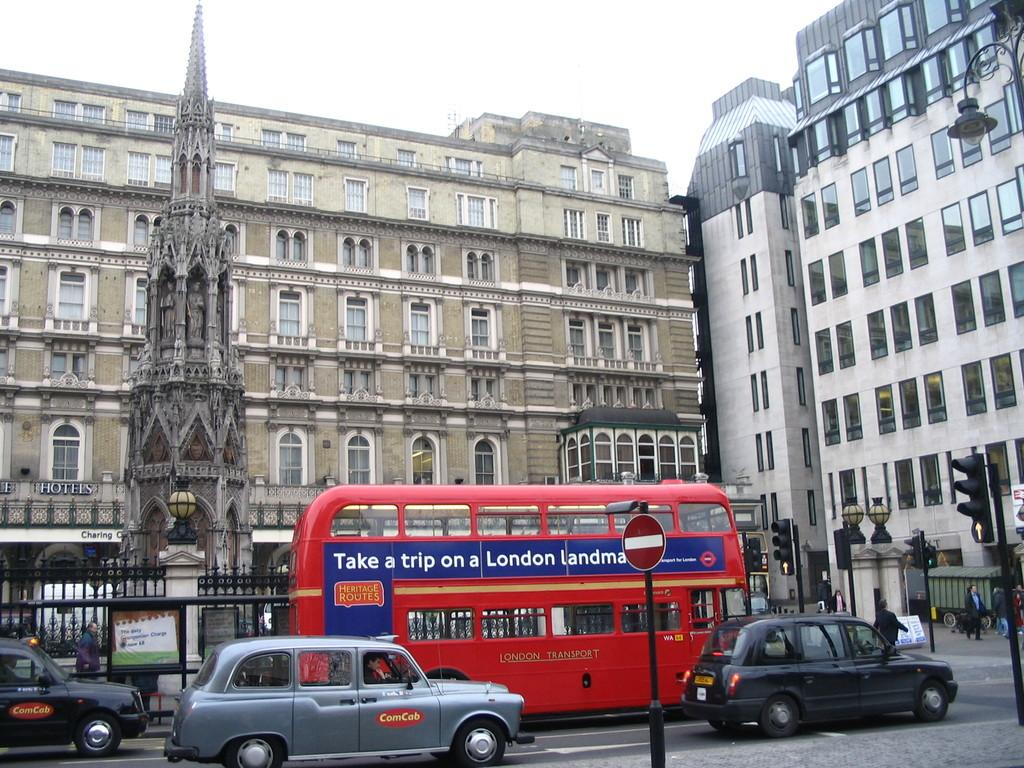<image>
Provide a brief description of the given image. A street in London with cars including a cab with a sign that says ComCab. 